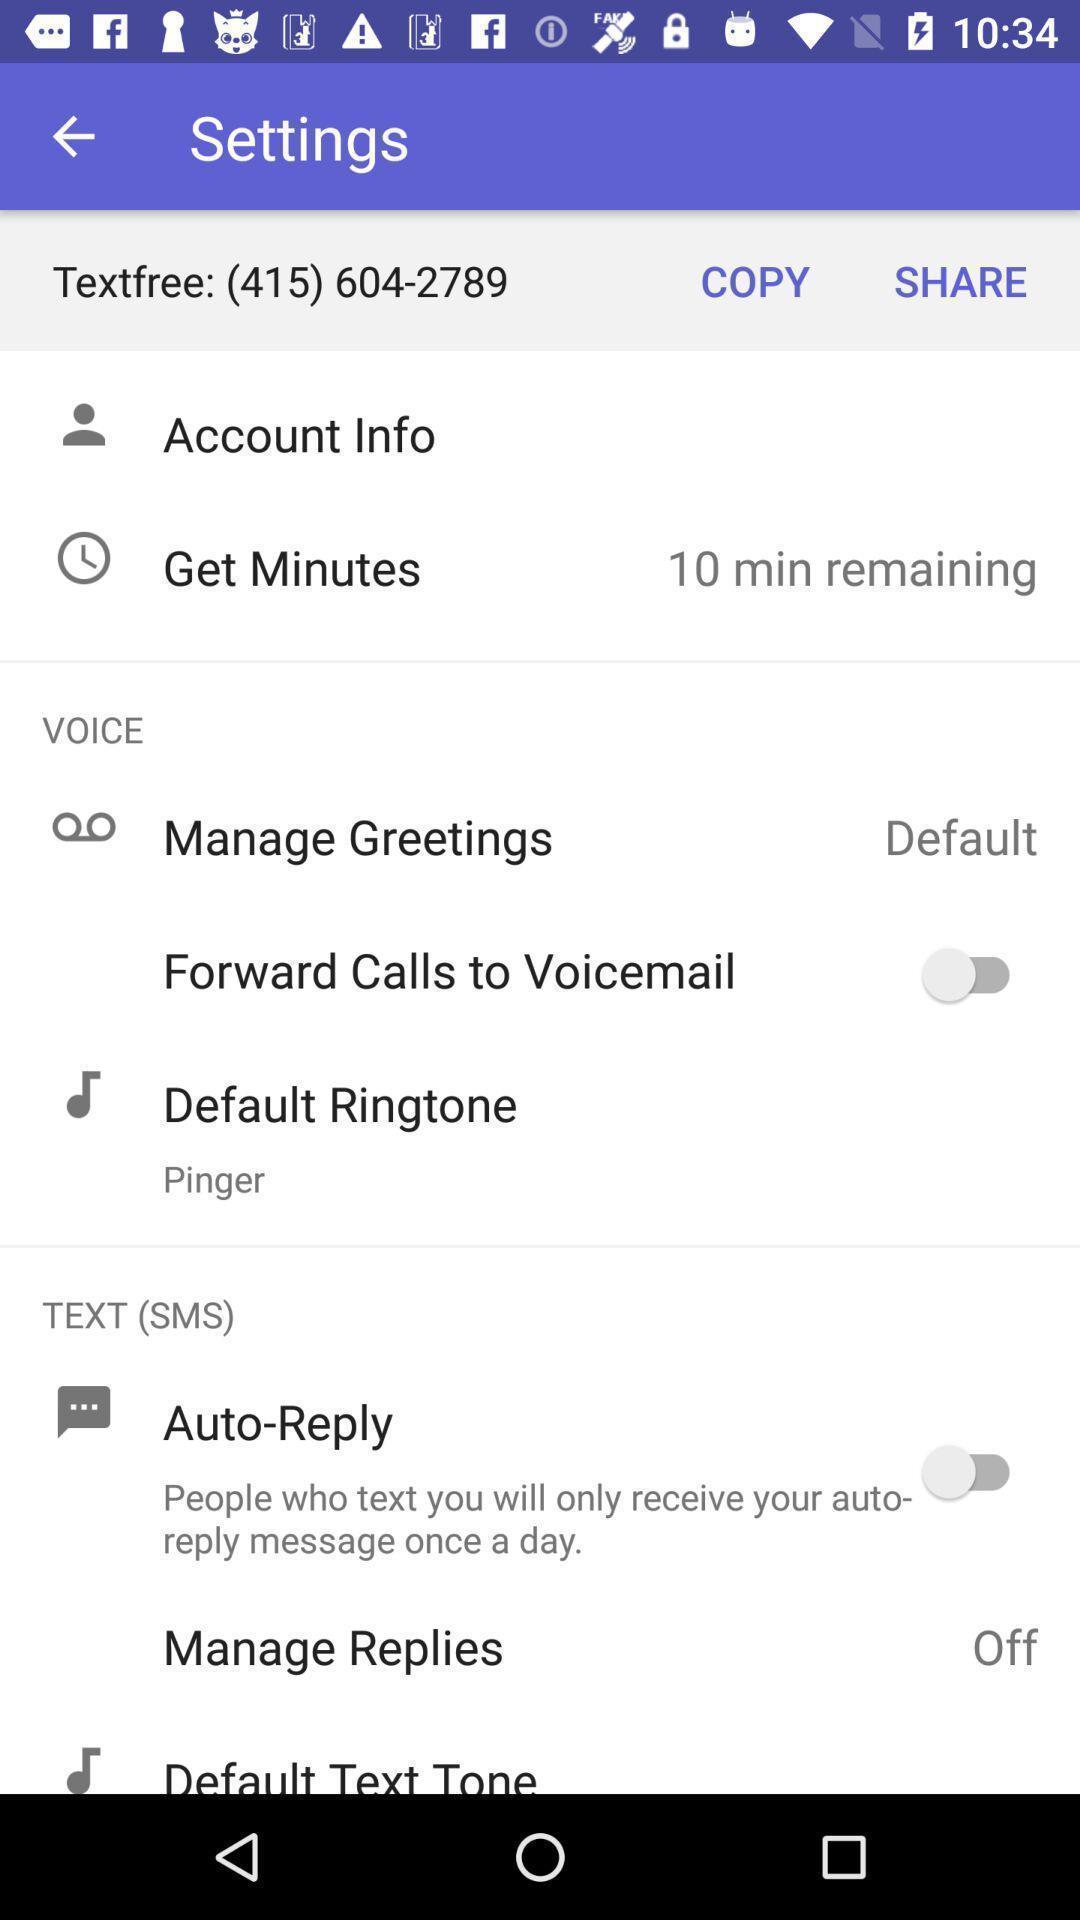Tell me about the visual elements in this screen capture. Settings page. 